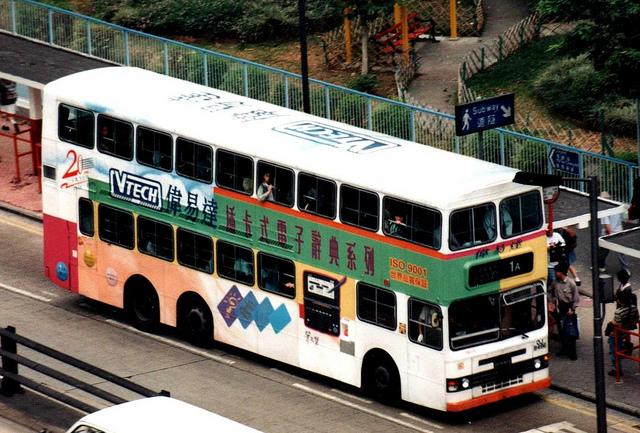On what side of the bus should they go if they want to take the metro? Please explain your reasoning. left. There is no door on the right so the door must be on the left. 